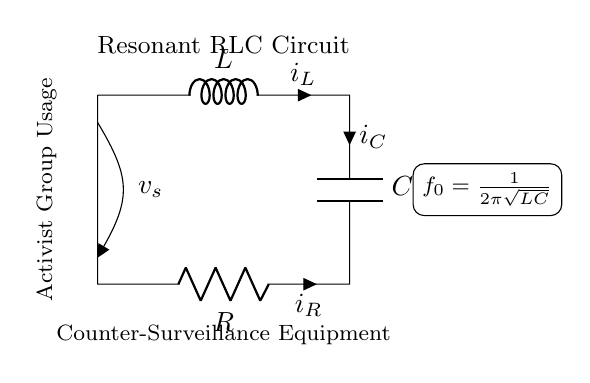What are the components in this circuit? The components in the circuit are an inductor, a capacitor, and a resistor. Each component is labeled in the diagram with L, C, and R, respectively.
Answer: Inductor, capacitor, resistor What is the current through the inductor denoted as? The current through the inductor is denoted as "i_L" in the circuit diagram. It is indicated next to the inductor symbol.
Answer: i_L What is the resonance frequency formula for this RLC circuit? The formula for resonance frequency in this circuit is given as f_0 = 1 / (2π√(LC)). It is placed in the diagram to represent how the inductance and capacitance relate to resonance.
Answer: f_0 = 1 / (2π√(LC)) What happens at resonance in this RLC circuit? At resonance, the inductive and capacitive reactances are equal (XL = XC), resulting in maximum current in the circuit. This is a fundamental principle of resonance in RLC circuits.
Answer: Maximum current Why is this circuit relevant to counter-surveillance equipment? This circuit is relevant because it's capable of filtering specific frequencies, which can be utilized for detecting or countering surveillance signals that use those frequencies. Activists may use it to protect privacy.
Answer: Signal filtering 